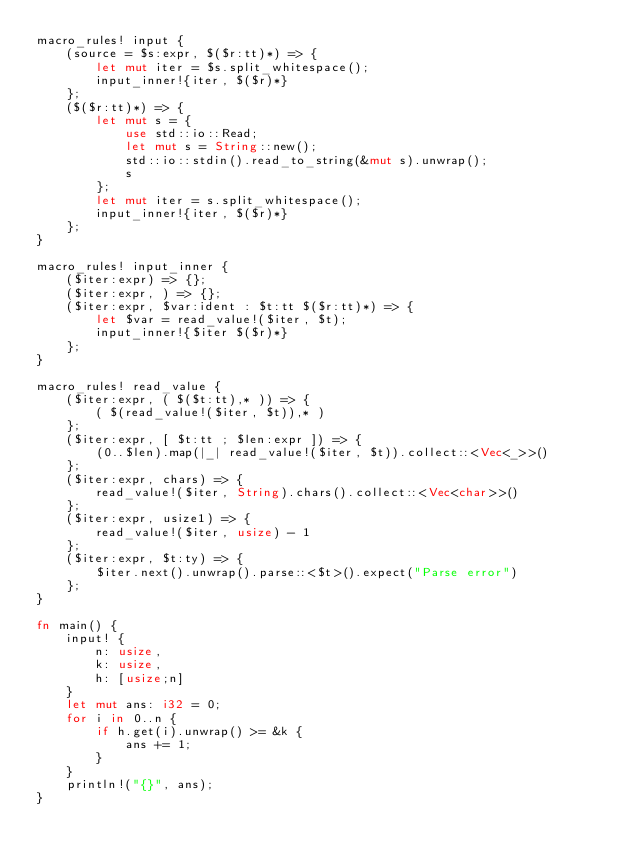<code> <loc_0><loc_0><loc_500><loc_500><_Rust_>macro_rules! input {
    (source = $s:expr, $($r:tt)*) => {
        let mut iter = $s.split_whitespace();
        input_inner!{iter, $($r)*}
    };
    ($($r:tt)*) => {
        let mut s = {
            use std::io::Read;
            let mut s = String::new();
            std::io::stdin().read_to_string(&mut s).unwrap();
            s
        };
        let mut iter = s.split_whitespace();
        input_inner!{iter, $($r)*}
    };
}

macro_rules! input_inner {
    ($iter:expr) => {};
    ($iter:expr, ) => {};
    ($iter:expr, $var:ident : $t:tt $($r:tt)*) => {
        let $var = read_value!($iter, $t);
        input_inner!{$iter $($r)*}
    };
}

macro_rules! read_value {
    ($iter:expr, ( $($t:tt),* )) => {
        ( $(read_value!($iter, $t)),* )
    };
    ($iter:expr, [ $t:tt ; $len:expr ]) => {
        (0..$len).map(|_| read_value!($iter, $t)).collect::<Vec<_>>()
    };
    ($iter:expr, chars) => {
        read_value!($iter, String).chars().collect::<Vec<char>>()
    };
    ($iter:expr, usize1) => {
        read_value!($iter, usize) - 1
    };
    ($iter:expr, $t:ty) => {
        $iter.next().unwrap().parse::<$t>().expect("Parse error")
    };
}

fn main() {
    input! {
        n: usize,
        k: usize,
        h: [usize;n]
    }
    let mut ans: i32 = 0;
    for i in 0..n {
        if h.get(i).unwrap() >= &k {
            ans += 1;
        }
    }
    println!("{}", ans);
}</code> 